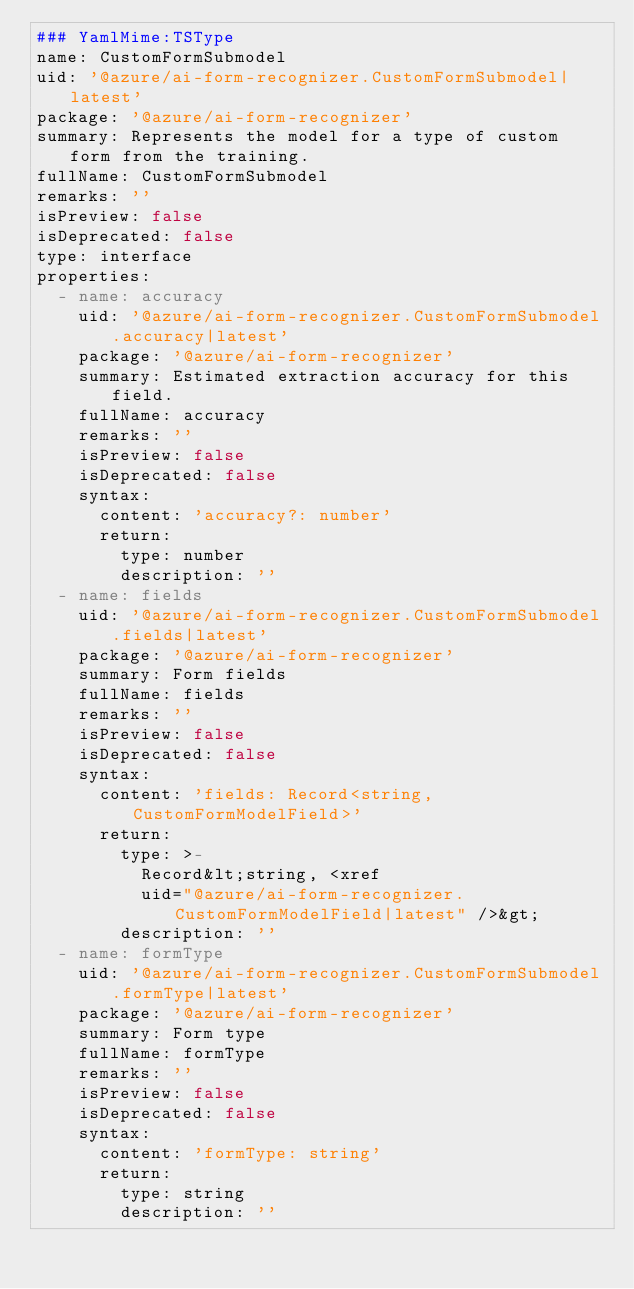Convert code to text. <code><loc_0><loc_0><loc_500><loc_500><_YAML_>### YamlMime:TSType
name: CustomFormSubmodel
uid: '@azure/ai-form-recognizer.CustomFormSubmodel|latest'
package: '@azure/ai-form-recognizer'
summary: Represents the model for a type of custom form from the training.
fullName: CustomFormSubmodel
remarks: ''
isPreview: false
isDeprecated: false
type: interface
properties:
  - name: accuracy
    uid: '@azure/ai-form-recognizer.CustomFormSubmodel.accuracy|latest'
    package: '@azure/ai-form-recognizer'
    summary: Estimated extraction accuracy for this field.
    fullName: accuracy
    remarks: ''
    isPreview: false
    isDeprecated: false
    syntax:
      content: 'accuracy?: number'
      return:
        type: number
        description: ''
  - name: fields
    uid: '@azure/ai-form-recognizer.CustomFormSubmodel.fields|latest'
    package: '@azure/ai-form-recognizer'
    summary: Form fields
    fullName: fields
    remarks: ''
    isPreview: false
    isDeprecated: false
    syntax:
      content: 'fields: Record<string, CustomFormModelField>'
      return:
        type: >-
          Record&lt;string, <xref
          uid="@azure/ai-form-recognizer.CustomFormModelField|latest" />&gt;
        description: ''
  - name: formType
    uid: '@azure/ai-form-recognizer.CustomFormSubmodel.formType|latest'
    package: '@azure/ai-form-recognizer'
    summary: Form type
    fullName: formType
    remarks: ''
    isPreview: false
    isDeprecated: false
    syntax:
      content: 'formType: string'
      return:
        type: string
        description: ''
</code> 